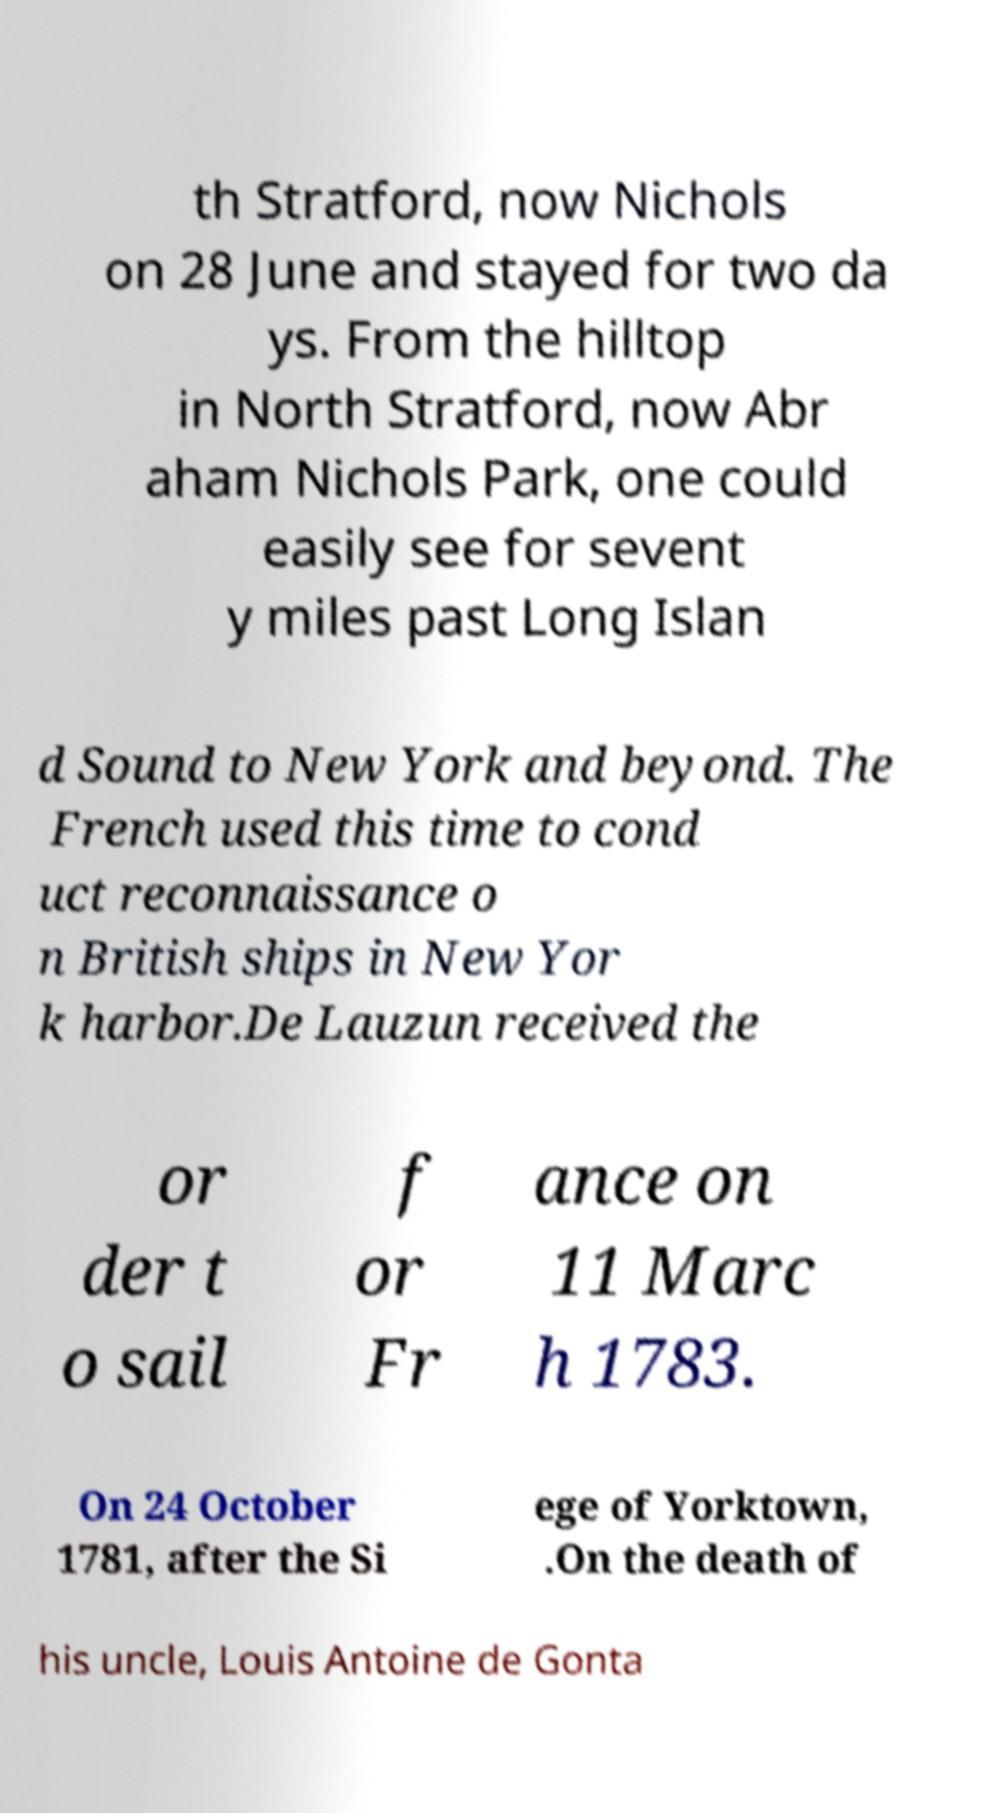For documentation purposes, I need the text within this image transcribed. Could you provide that? th Stratford, now Nichols on 28 June and stayed for two da ys. From the hilltop in North Stratford, now Abr aham Nichols Park, one could easily see for sevent y miles past Long Islan d Sound to New York and beyond. The French used this time to cond uct reconnaissance o n British ships in New Yor k harbor.De Lauzun received the or der t o sail f or Fr ance on 11 Marc h 1783. On 24 October 1781, after the Si ege of Yorktown, .On the death of his uncle, Louis Antoine de Gonta 